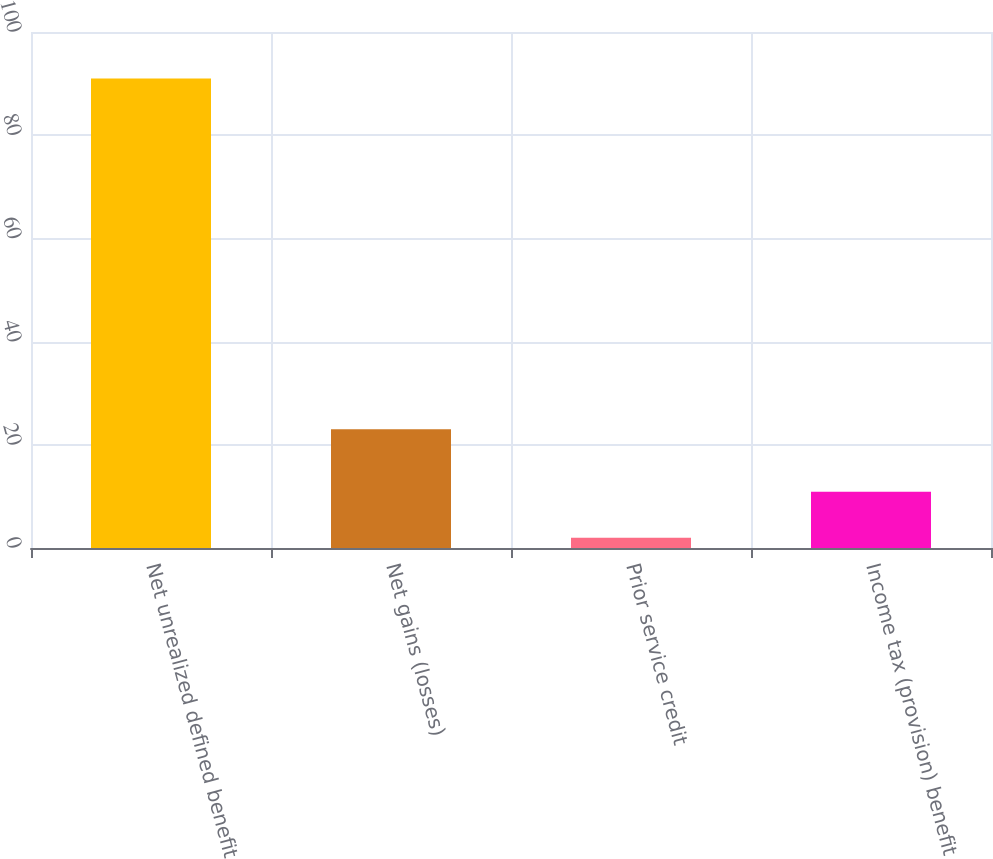Convert chart to OTSL. <chart><loc_0><loc_0><loc_500><loc_500><bar_chart><fcel>Net unrealized defined benefit<fcel>Net gains (losses)<fcel>Prior service credit<fcel>Income tax (provision) benefit<nl><fcel>91<fcel>23<fcel>2<fcel>10.9<nl></chart> 